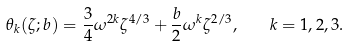Convert formula to latex. <formula><loc_0><loc_0><loc_500><loc_500>\theta _ { k } ( \zeta ; b ) = \frac { 3 } { 4 } \omega ^ { 2 k } \zeta ^ { 4 / 3 } + \frac { b } { 2 } \omega ^ { k } \zeta ^ { 2 / 3 } , \quad k = 1 , 2 , 3 .</formula> 